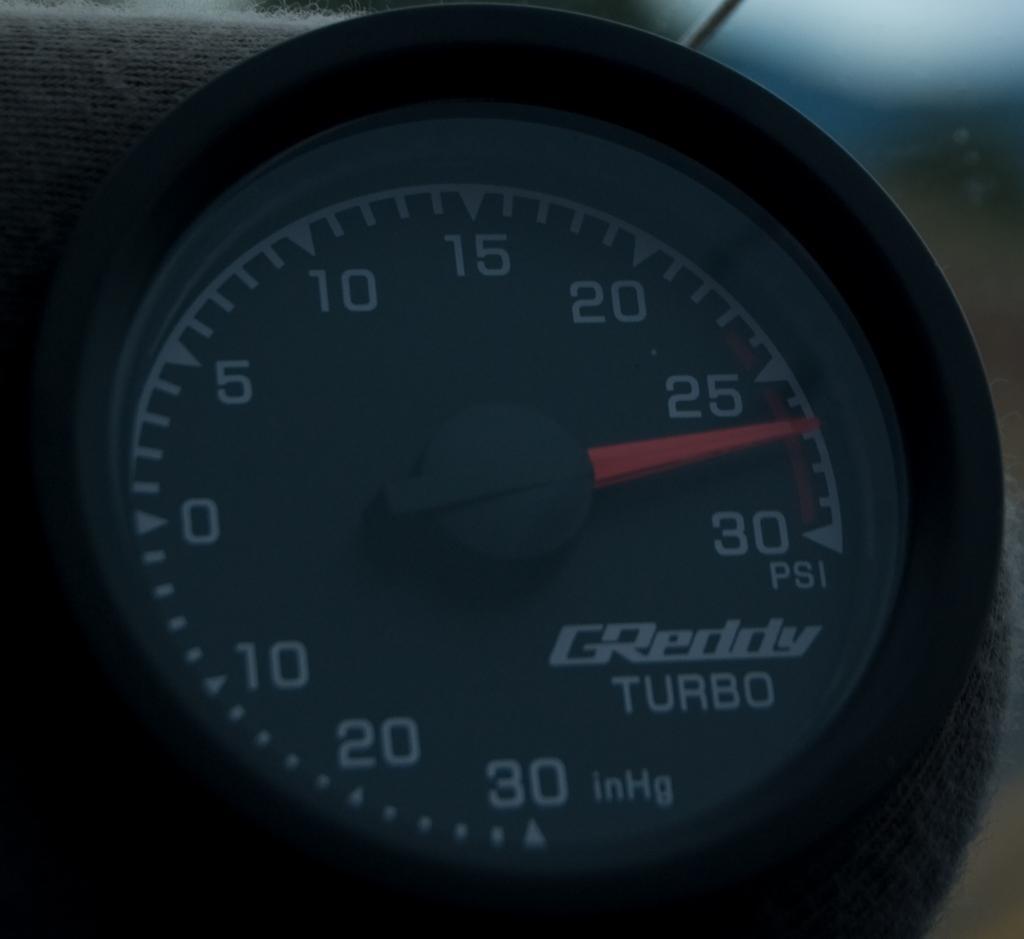Can you describe this image briefly? In the picture we can see a speed-o- meter with a name on it as greddy turbo. 